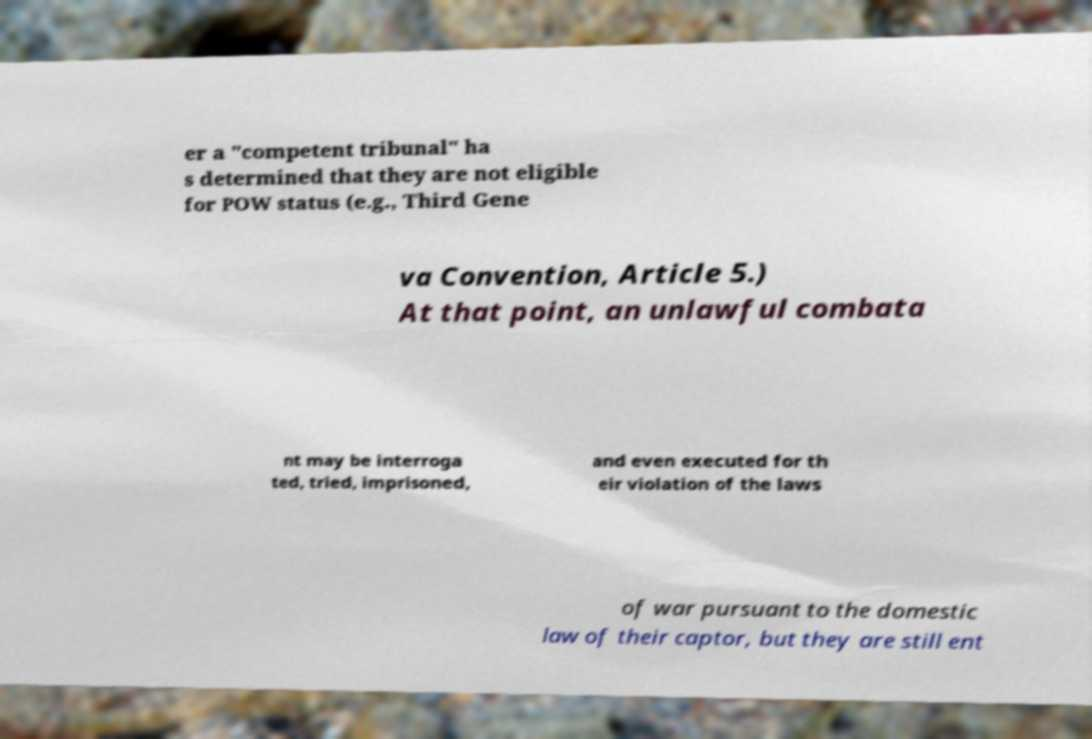I need the written content from this picture converted into text. Can you do that? er a "competent tribunal" ha s determined that they are not eligible for POW status (e.g., Third Gene va Convention, Article 5.) At that point, an unlawful combata nt may be interroga ted, tried, imprisoned, and even executed for th eir violation of the laws of war pursuant to the domestic law of their captor, but they are still ent 